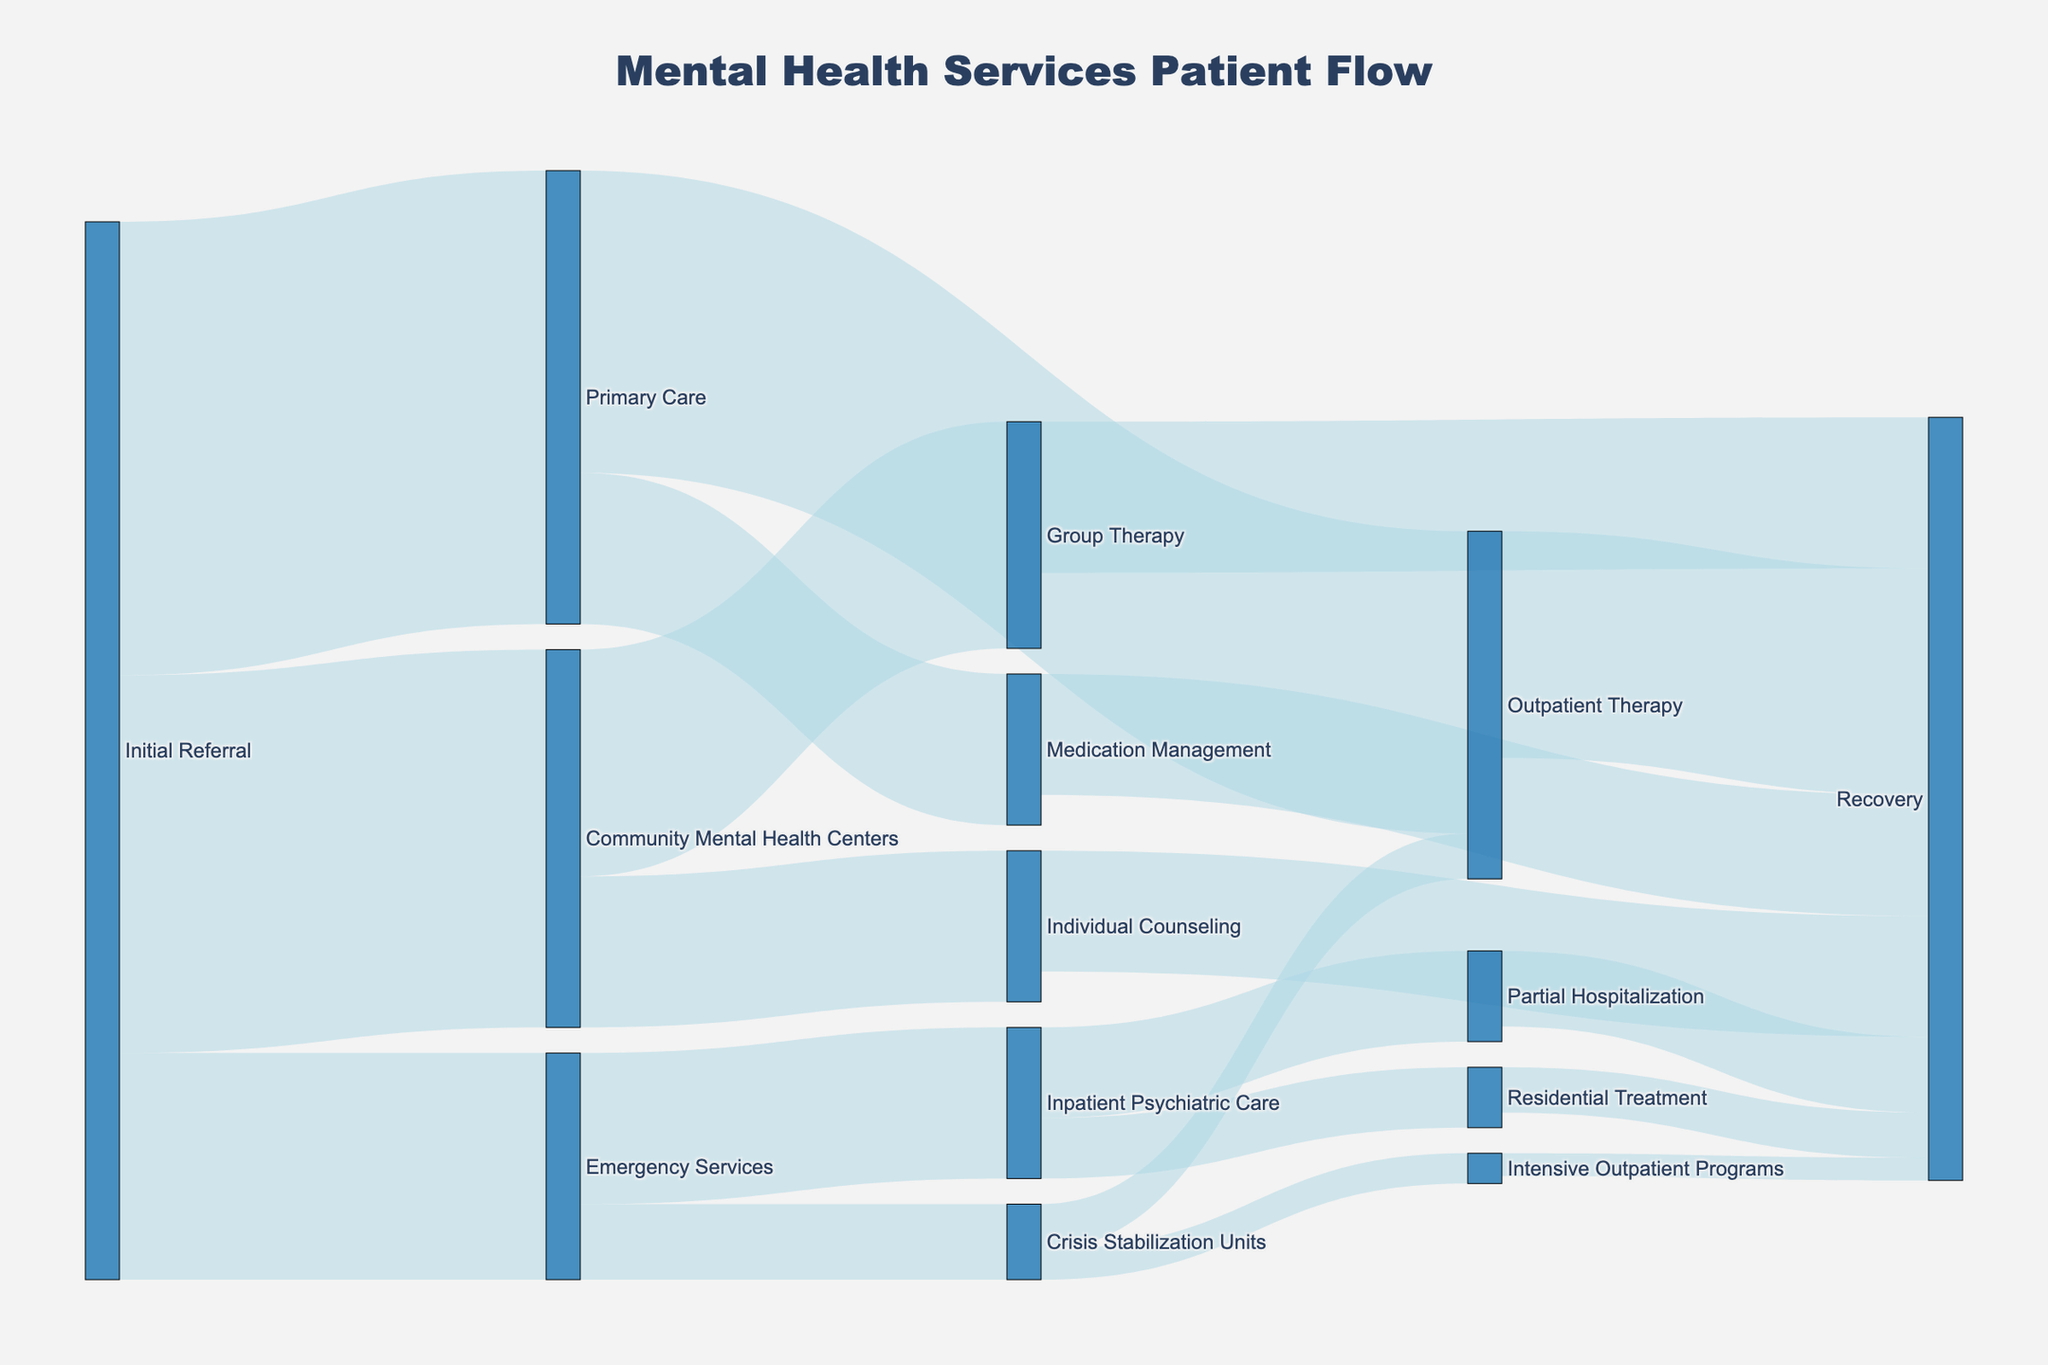Which service receives the largest number of initial referrals? The nodes connecting to "Initial Referral" are "Emergency Services", "Primary Care", and "Community Mental Health Centers". By checking the values, "Primary Care" receives 300 initial referrals.
Answer: Primary Care How many patients are referred to Community Mental Health Centers from the initial referral? The value linking "Initial Referral" to "Community Mental Health Centers" is 250.
Answer: 250 Calculate the total number of patients who recover through Outpatient Therapy, Medication Management, Group Therapy, and Individual Counseling. Add values from "Outpatient Therapy" to "Recovery" (150), "Medication Management" to "Recovery" (80), "Group Therapy" to "Recovery" (100), and "Individual Counseling" to "Recovery" (80). Therefore, 150 + 80 + 100 + 80 = 410.
Answer: 410 Which service, between Emergency Services and Community Mental Health Centers, results in a higher number of recoveries through various pathways? Emergency Services leads to recoveries via "Inpatient Psychiatric Care", "Crisis Stabilization Units", while Community Mental Health Centers lead to "Group Therapy" and "Individual Counseling". Summing up, "Emergency Services": 150 (100 + 50) and "Community Mental Health Centers": 250 (150 + 100), with some of the paths leading ultimately to recoveries. Community Mental Health Centers contribute to a higher number of recoveries.
Answer: Community Mental Health Centers Compare the number of patients transitioning from Emergency Services to Crisis Stabilization Units with those transitioning to Inpatient Psychiatric Care. Value linking Emergency Services to Inpatient Psychiatric Care is 100 and to Crisis Stabilization Units is 50. So, Inpatient Psychiatric Care has more patients.
Answer: Inpatient Psychiatric Care How many patients who started in primary care end up in recovery through any route? Check values for "Primary Care" routes leading to "Recovery": "Outpatient Therapy" (200), "Medication Management" (100). Adding up: 150 (Outpatient Therapy to Recovery) + 80 (Medication Management to Recovery) = 230.
Answer: 230 Which pathway leads to the least number of recoveries in the diagram? Check the values for paths leading to "Recovery". "Intensive Outpatient Programs" to "Recovery" has the smallest value, which is 15.
Answer: Intensive Outpatient Programs What is the title of the Sankey diagram? The title at the top of the diagram reads “Mental Health Services Patient Flow.”
Answer: Mental Health Services Patient Flow How many paths lead to the Recovery node directly or indirectly? Paths leading to "Recovery" are from "Outpatient Therapy", "Medication Management", "Group Therapy", "Individual Counseling", "Partial Hospitalization", "Residential Treatment" and "Intensive Outpatient Programs". Therefore, there are 7 paths.
Answer: 7 